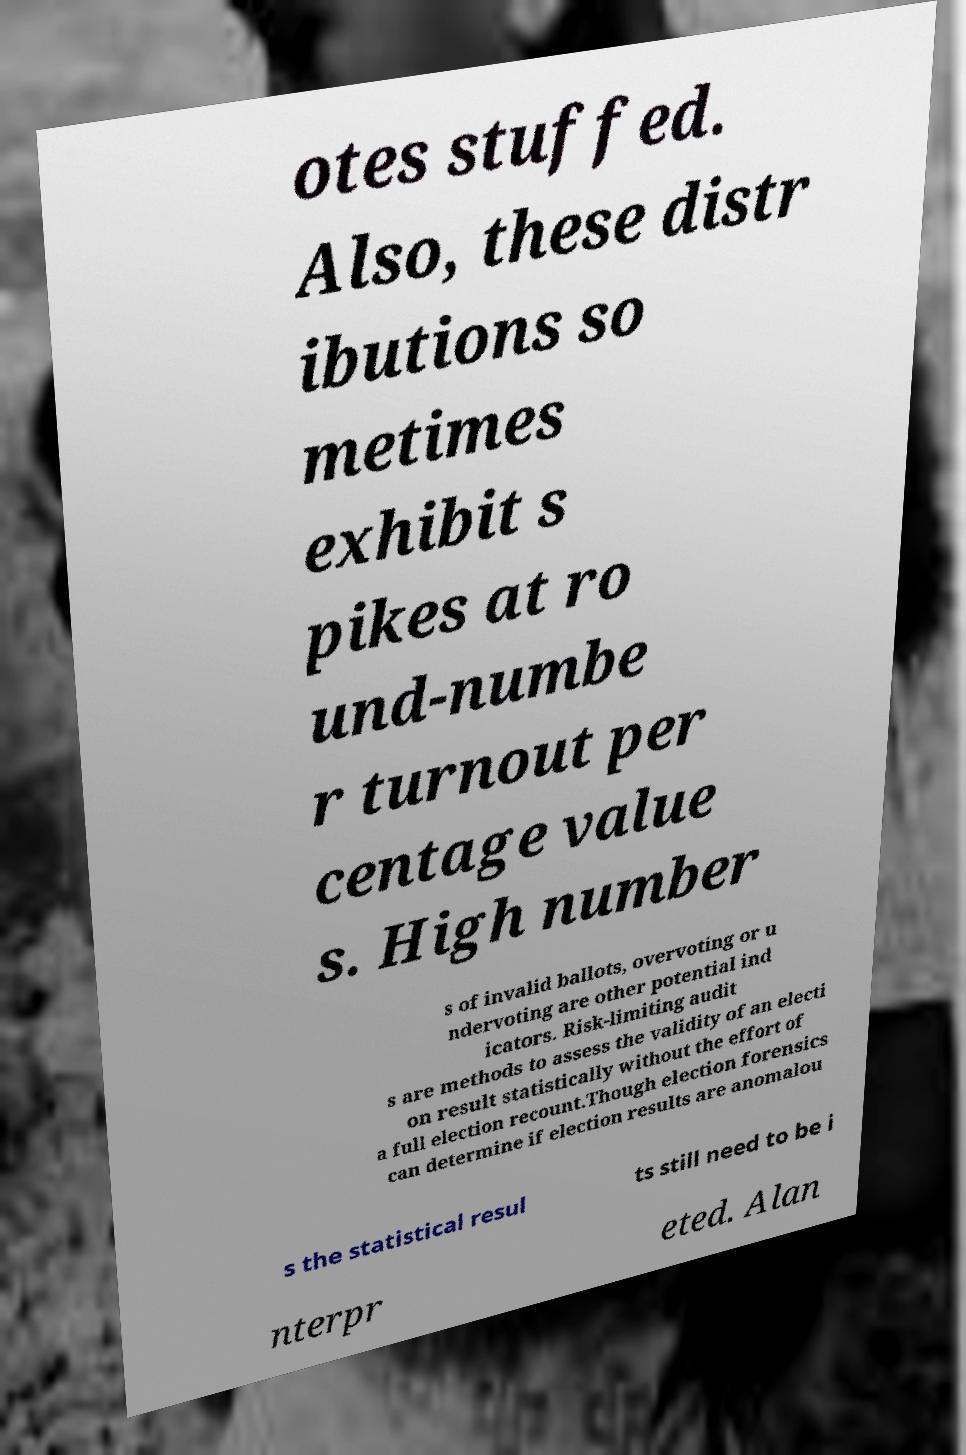For documentation purposes, I need the text within this image transcribed. Could you provide that? otes stuffed. Also, these distr ibutions so metimes exhibit s pikes at ro und-numbe r turnout per centage value s. High number s of invalid ballots, overvoting or u ndervoting are other potential ind icators. Risk-limiting audit s are methods to assess the validity of an electi on result statistically without the effort of a full election recount.Though election forensics can determine if election results are anomalou s the statistical resul ts still need to be i nterpr eted. Alan 